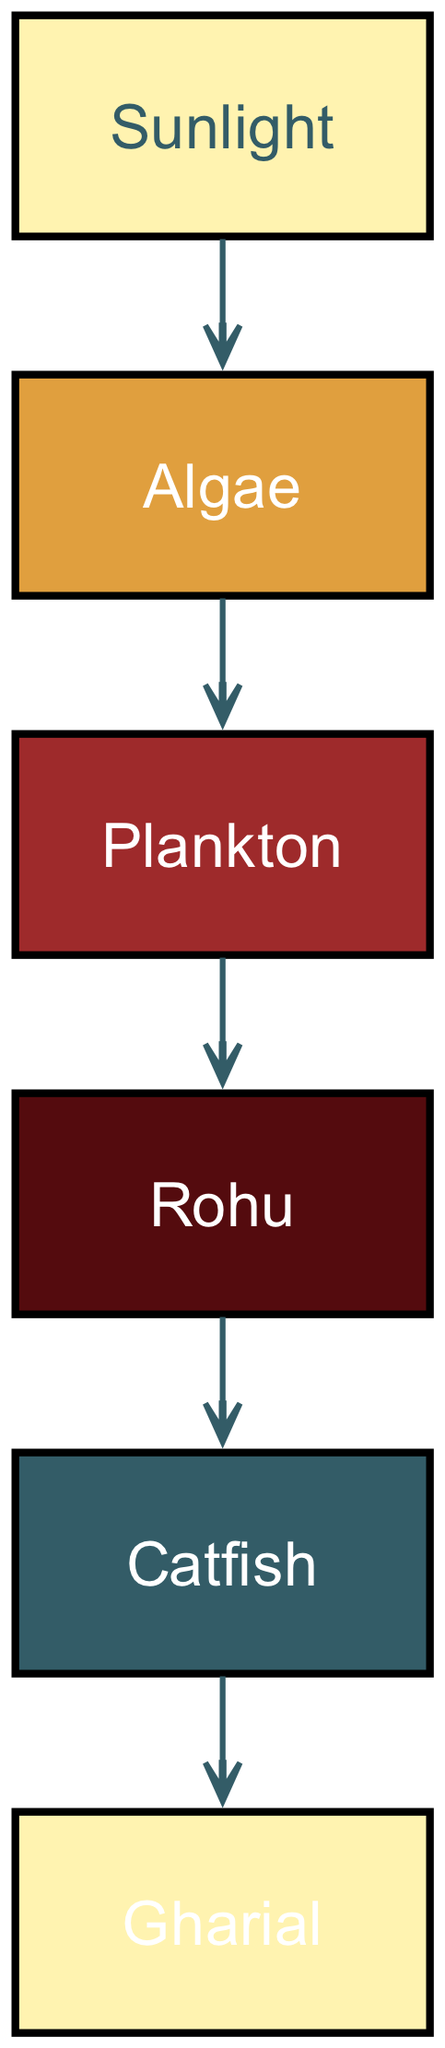What is the primary source of energy in the aquatic food chain? The diagram shows sunlight at the top, indicating that it is the primary energy source that powers the food chain.
Answer: Sunlight How many levels are present in the food chain? The diagram includes five distinct levels of organisms: sunlight, algae, plankton, small fish, and large fish leading to the gharial, totaling six elements.
Answer: 6 Which organism is at the second level of the food chain? The second level in the diagram is represented by algae, which has a direct connection to the energy source, sunlight.
Answer: Algae What type of fish is shown at the third level? The diagram indicates the small fish is represented as Rohu, which occupies the third level in the food chain.
Answer: Rohu Which organism is the final consumer at the highest level of the food chain? The diagram shows that the gharial is the last organism in the food chain, indicating it is the final consumer at the highest level.
Answer: Gharial What is the direct relationship between algae and plankton? The edge connecting algae to plankton indicates that algae is consumed by plankton, signifying a direct relationship in the food chain.
Answer: Algae is consumed by plankton How many edges are there in the food chain? The diagram contains five edges connecting the six elements, one for each transfer of energy from one level to another.
Answer: 5 What type of organism is the Catfish classified as in this food chain? The Catfish appears at the fourth level and is a large fish, classified as a predatory organism in the food chain.
Answer: Large fish Which organism directly feeds on the small fish? The diagram illustrates that the large fish, symbolized as Catfish, directly feeds on the small fish, indicating a predator-prey relationship.
Answer: Catfish 